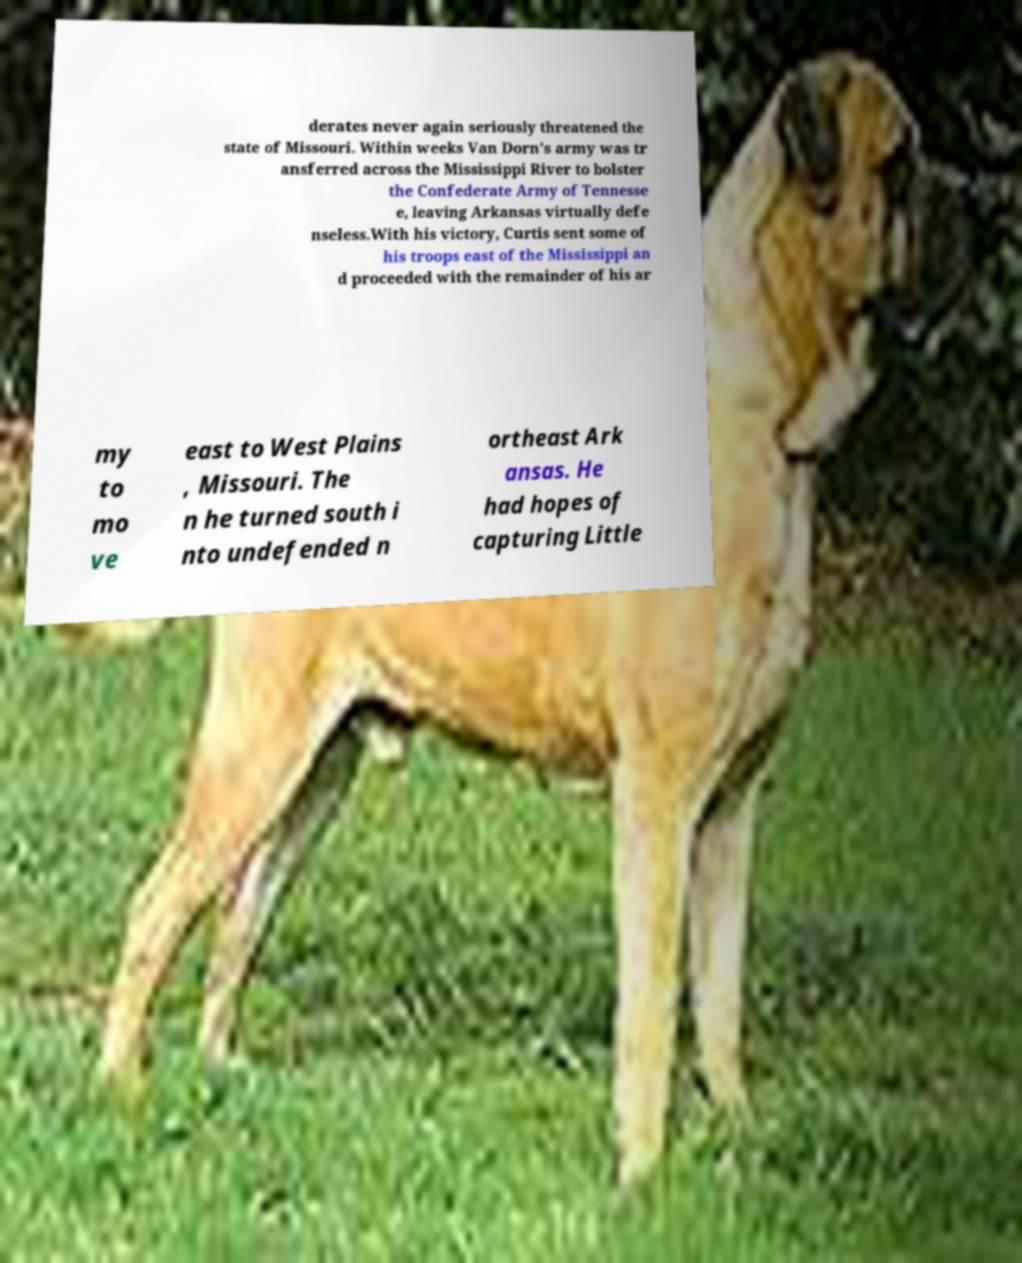I need the written content from this picture converted into text. Can you do that? derates never again seriously threatened the state of Missouri. Within weeks Van Dorn's army was tr ansferred across the Mississippi River to bolster the Confederate Army of Tennesse e, leaving Arkansas virtually defe nseless.With his victory, Curtis sent some of his troops east of the Mississippi an d proceeded with the remainder of his ar my to mo ve east to West Plains , Missouri. The n he turned south i nto undefended n ortheast Ark ansas. He had hopes of capturing Little 